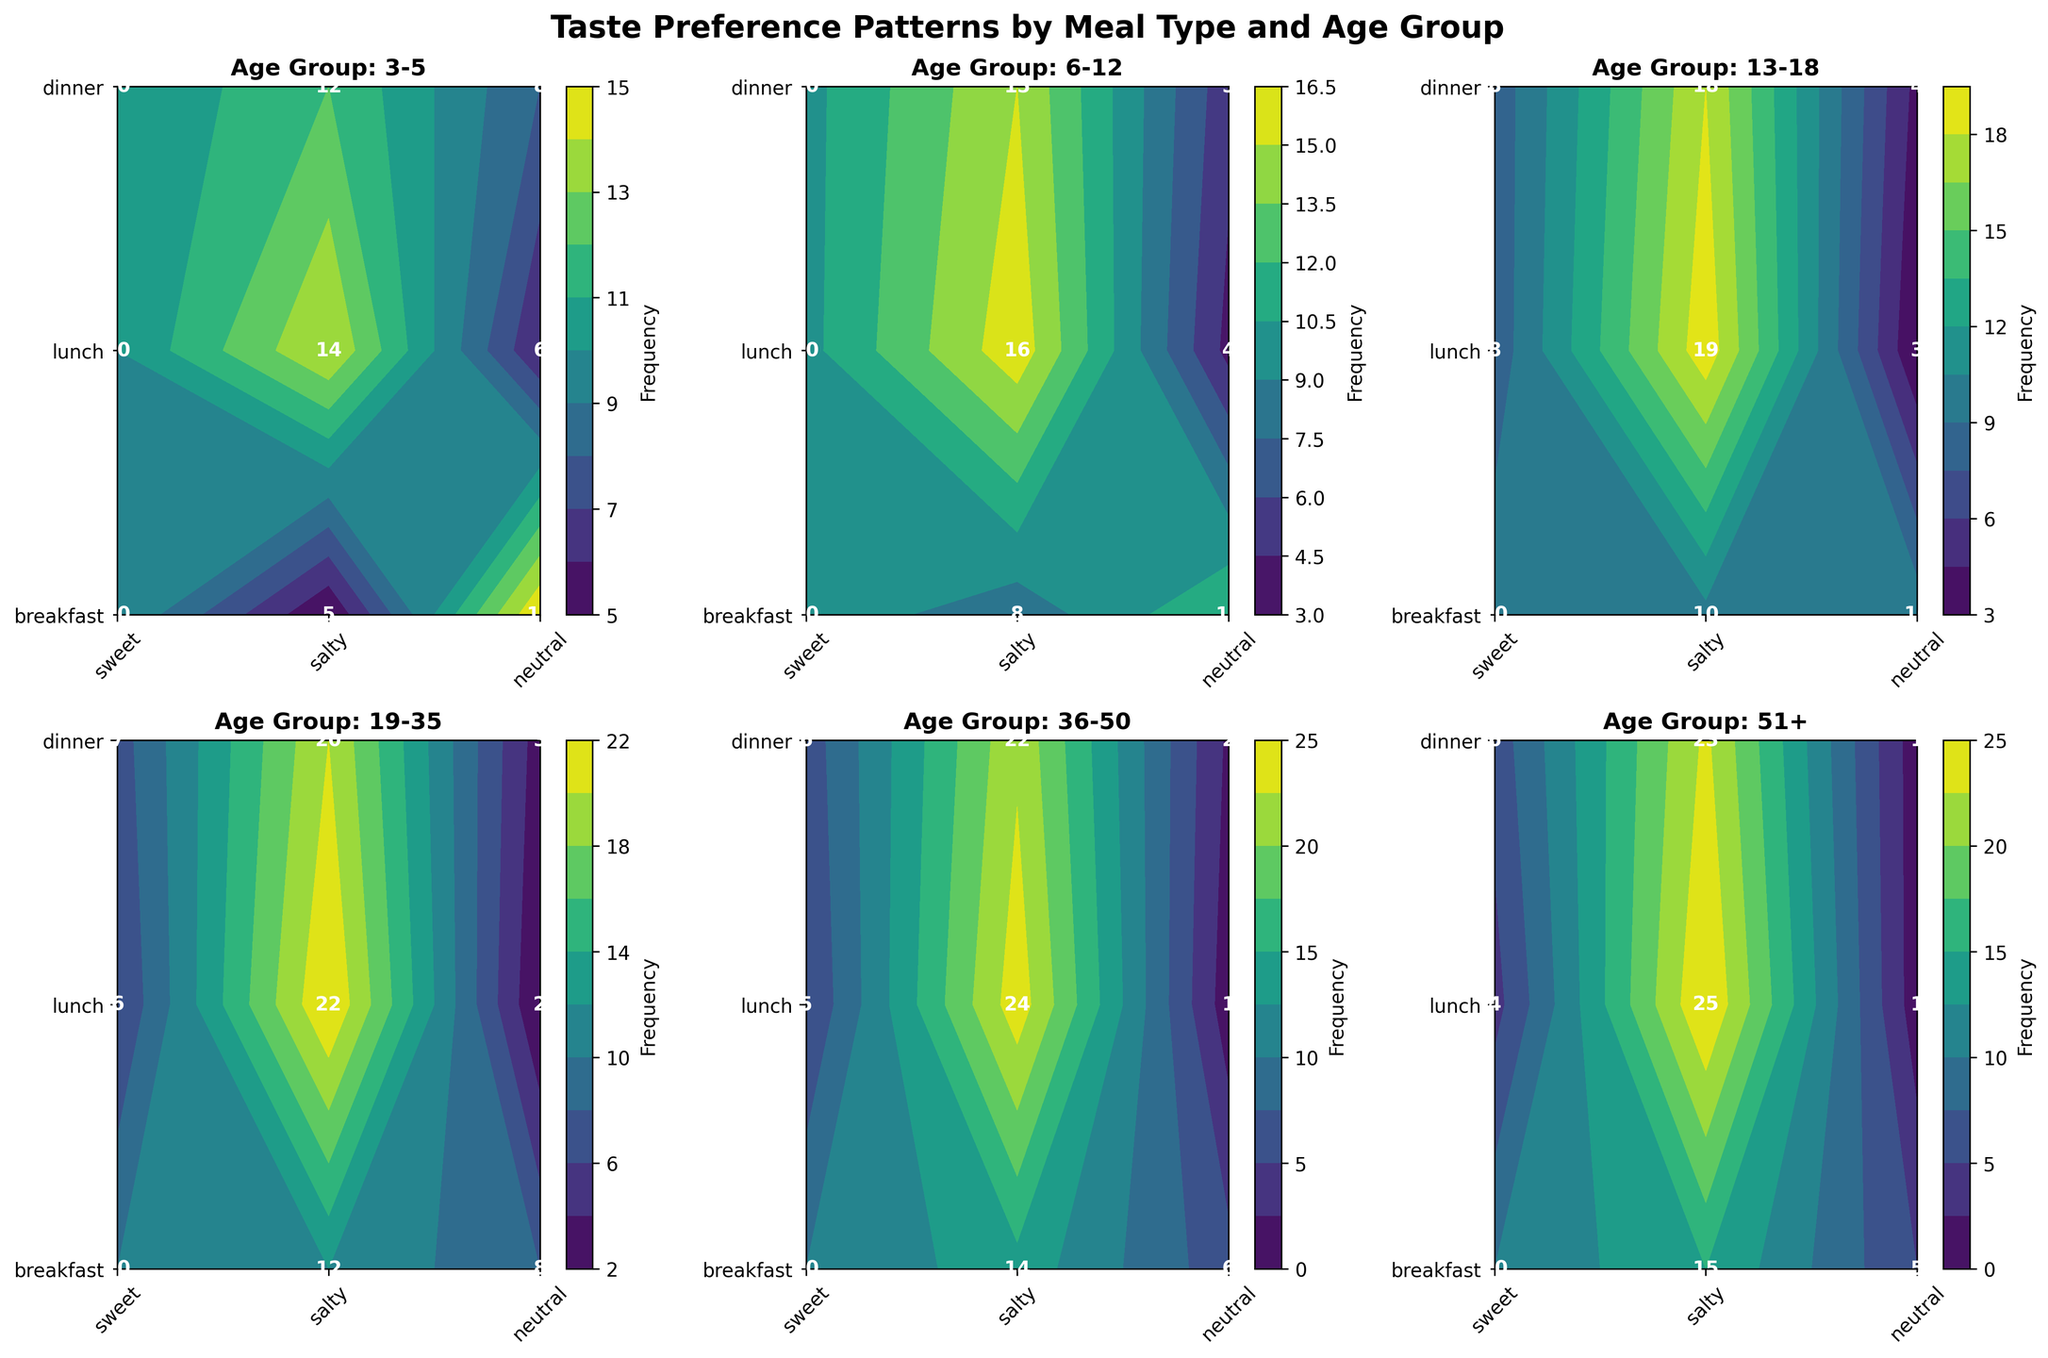what is the title of the contour plots? The title of the contour plots is typically placed at the center top. In this case, the title is "Taste Preference Patterns by Meal Type and Age Group".
Answer: Taste Preference Patterns by Meal Type and Age Group which age group prefers salty tastes the most at dinner? The contour levels and annotations in the dinner subplot can be checked. The age group "51+" shows the highest frequency with 25 occurrences of salty taste preference.
Answer: 51+ for the "3-5" age group, how does the preference for sweet vs. salty change when moving from breakfast to lunch? For breakfast, the frequency of sweet is 15 and salty is 5. For lunch, sweet is 8 and salty is 12. By subtracting the lunch values from the breakfast values, the sweet preference decreases by 7, and salty preference increases by 7.
Answer: Sweet decreases by 7, salty increases by 7 in which meal type does the "19-35" age group show the least preference for sweet foods? For the "19-35" age group, breakfast has a frequency of 8, lunch has 3, and dinner has 2. The least preference is shown in dinner with a frequency of 2.
Answer: Dinner compare the sweet taste preferences for breakfast and lunch between the "6-12" and "13-18" age groups. Which age group shows a greater difference? For the "6-12" age group, breakfast has 12 and lunch has 5, which is a difference of 7. For the "13-18" age group, breakfast has 10 and lunch has 4, a difference of 6. The "6-12" age group shows the greater difference.
Answer: 6-12 what is the frequency of neutral taste preference for the "36-50" age group during lunch? The frequency is indicated on the plot in the "36-50" age group lunch interval. The labeled number is 6.
Answer: 6 which age group shows the most balanced preference for all taste types during breakfast? The contour levels and labels indicate balance. For the "13-18" age group, all preferences (sweet, salty, neutral) have a recorded frequency of 10 each, showing equal balance.
Answer: 13-18 what is the axis representing meal types for the plot of the "3-5" age group? The meal types are listed on the y-axis (vertical axis) of the plot.
Answer: y-axis how many unique age groups are analyzed in the contour plot figure? By counting the unique age groups displayed across the subplots, there are six age groups ("3-5", "6-12", "13-18", "19-35", "36-50", "51+").
Answer: 6 